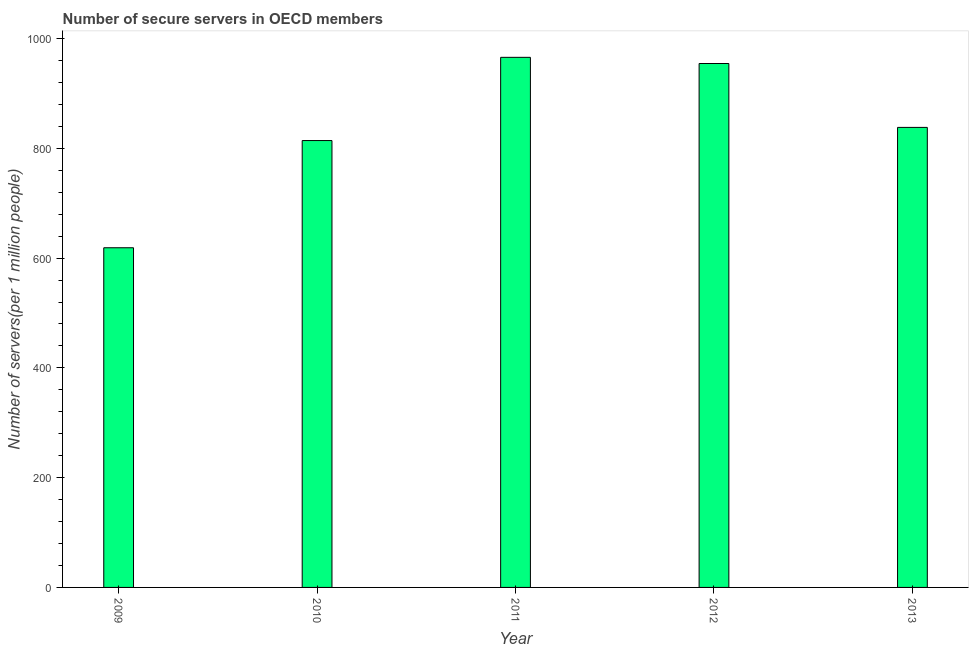Does the graph contain any zero values?
Provide a succinct answer. No. Does the graph contain grids?
Your answer should be compact. No. What is the title of the graph?
Provide a succinct answer. Number of secure servers in OECD members. What is the label or title of the Y-axis?
Ensure brevity in your answer.  Number of servers(per 1 million people). What is the number of secure internet servers in 2013?
Ensure brevity in your answer.  838.2. Across all years, what is the maximum number of secure internet servers?
Make the answer very short. 965.86. Across all years, what is the minimum number of secure internet servers?
Offer a very short reply. 618.91. In which year was the number of secure internet servers minimum?
Make the answer very short. 2009. What is the sum of the number of secure internet servers?
Your answer should be compact. 4191.78. What is the difference between the number of secure internet servers in 2010 and 2012?
Provide a short and direct response. -140.38. What is the average number of secure internet servers per year?
Ensure brevity in your answer.  838.36. What is the median number of secure internet servers?
Provide a short and direct response. 838.2. In how many years, is the number of secure internet servers greater than 160 ?
Your answer should be very brief. 5. Do a majority of the years between 2013 and 2012 (inclusive) have number of secure internet servers greater than 360 ?
Keep it short and to the point. No. What is the ratio of the number of secure internet servers in 2010 to that in 2013?
Your response must be concise. 0.97. What is the difference between the highest and the second highest number of secure internet servers?
Your response must be concise. 11.27. What is the difference between the highest and the lowest number of secure internet servers?
Your answer should be compact. 346.96. What is the Number of servers(per 1 million people) in 2009?
Ensure brevity in your answer.  618.91. What is the Number of servers(per 1 million people) of 2010?
Provide a succinct answer. 814.21. What is the Number of servers(per 1 million people) in 2011?
Offer a terse response. 965.86. What is the Number of servers(per 1 million people) in 2012?
Your answer should be compact. 954.59. What is the Number of servers(per 1 million people) of 2013?
Make the answer very short. 838.2. What is the difference between the Number of servers(per 1 million people) in 2009 and 2010?
Your answer should be very brief. -195.31. What is the difference between the Number of servers(per 1 million people) in 2009 and 2011?
Make the answer very short. -346.96. What is the difference between the Number of servers(per 1 million people) in 2009 and 2012?
Provide a succinct answer. -335.69. What is the difference between the Number of servers(per 1 million people) in 2009 and 2013?
Your answer should be compact. -219.3. What is the difference between the Number of servers(per 1 million people) in 2010 and 2011?
Offer a terse response. -151.65. What is the difference between the Number of servers(per 1 million people) in 2010 and 2012?
Your answer should be compact. -140.38. What is the difference between the Number of servers(per 1 million people) in 2010 and 2013?
Give a very brief answer. -23.99. What is the difference between the Number of servers(per 1 million people) in 2011 and 2012?
Offer a terse response. 11.27. What is the difference between the Number of servers(per 1 million people) in 2011 and 2013?
Provide a short and direct response. 127.66. What is the difference between the Number of servers(per 1 million people) in 2012 and 2013?
Offer a very short reply. 116.39. What is the ratio of the Number of servers(per 1 million people) in 2009 to that in 2010?
Give a very brief answer. 0.76. What is the ratio of the Number of servers(per 1 million people) in 2009 to that in 2011?
Give a very brief answer. 0.64. What is the ratio of the Number of servers(per 1 million people) in 2009 to that in 2012?
Your response must be concise. 0.65. What is the ratio of the Number of servers(per 1 million people) in 2009 to that in 2013?
Offer a very short reply. 0.74. What is the ratio of the Number of servers(per 1 million people) in 2010 to that in 2011?
Your response must be concise. 0.84. What is the ratio of the Number of servers(per 1 million people) in 2010 to that in 2012?
Your answer should be very brief. 0.85. What is the ratio of the Number of servers(per 1 million people) in 2011 to that in 2013?
Provide a succinct answer. 1.15. What is the ratio of the Number of servers(per 1 million people) in 2012 to that in 2013?
Provide a short and direct response. 1.14. 